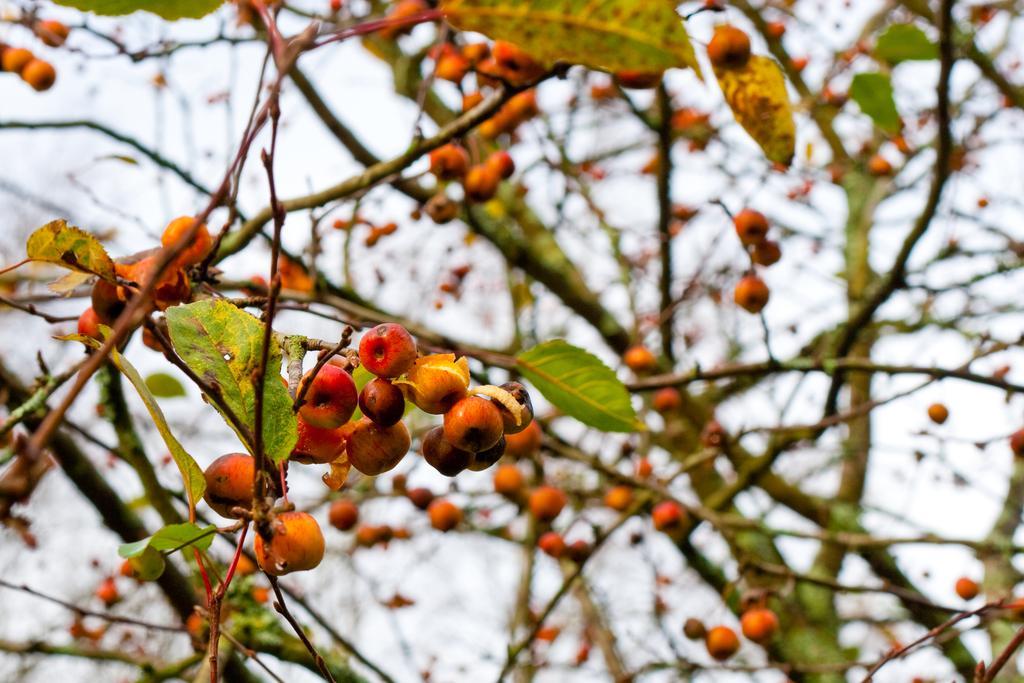Could you give a brief overview of what you see in this image? In this image, we can see some trees with fruits. We can also see the sky. 